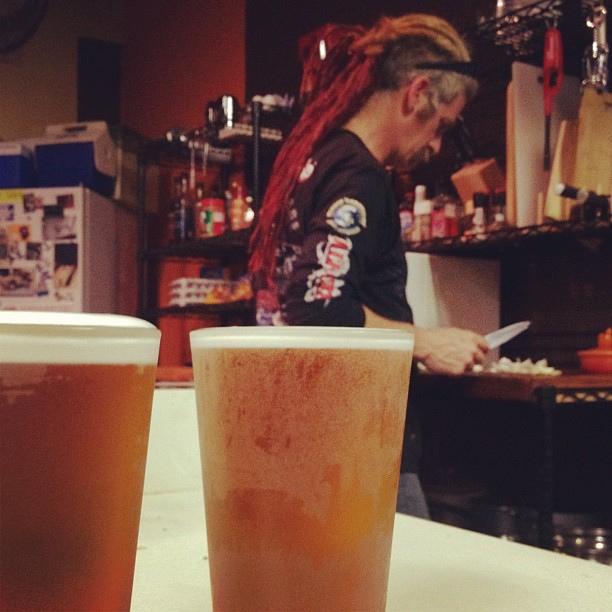What is the man holding?
Keep it brief. Knife. What is in the glasses?
Short answer required. Beer. How is the man's hair styled?
Short answer required. Dreadlocks. 